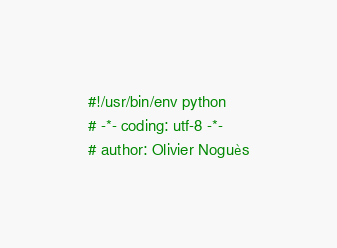Convert code to text. <code><loc_0><loc_0><loc_500><loc_500><_Python_>#!/usr/bin/env python
# -*- coding: utf-8 -*-
# author: Olivier Noguès

</code> 